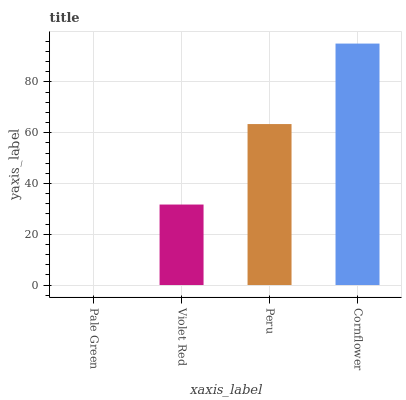Is Cornflower the maximum?
Answer yes or no. Yes. Is Violet Red the minimum?
Answer yes or no. No. Is Violet Red the maximum?
Answer yes or no. No. Is Violet Red greater than Pale Green?
Answer yes or no. Yes. Is Pale Green less than Violet Red?
Answer yes or no. Yes. Is Pale Green greater than Violet Red?
Answer yes or no. No. Is Violet Red less than Pale Green?
Answer yes or no. No. Is Peru the high median?
Answer yes or no. Yes. Is Violet Red the low median?
Answer yes or no. Yes. Is Violet Red the high median?
Answer yes or no. No. Is Cornflower the low median?
Answer yes or no. No. 